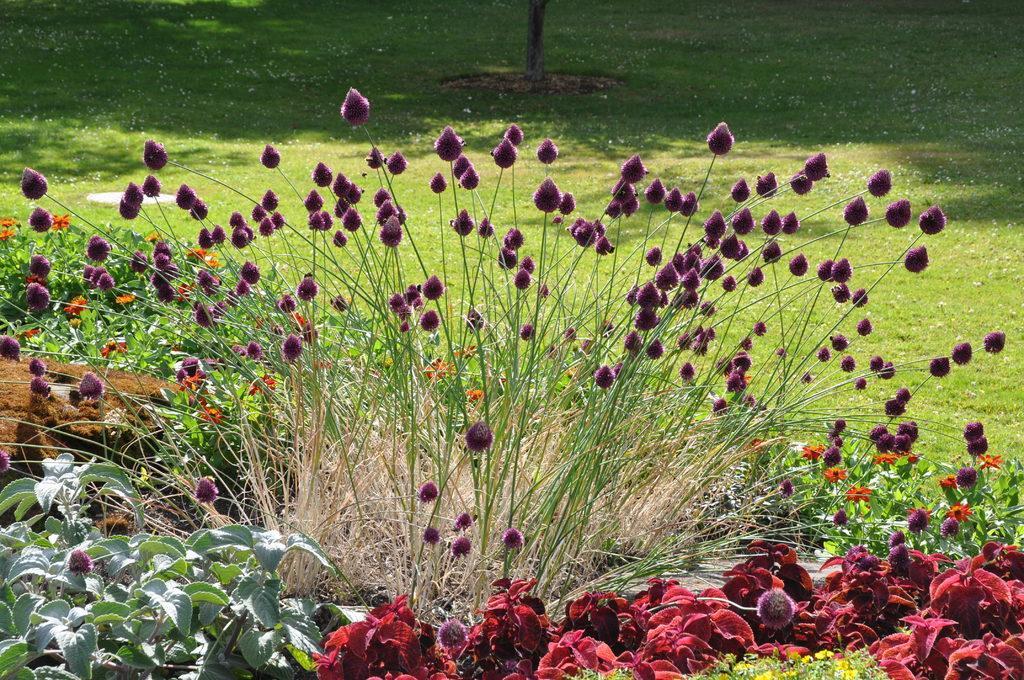Could you give a brief overview of what you see in this image? In this image, we can see plants and there are flowers which are in violet color. In the background, there is a tree. At the bottom, there is ground. 